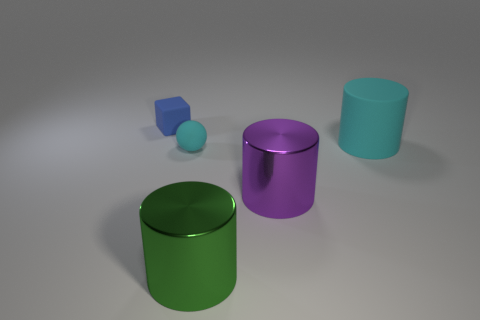Subtract all green cylinders. How many cylinders are left? 2 Subtract all purple cylinders. How many cylinders are left? 2 Add 3 big green things. How many objects exist? 8 Subtract 1 cylinders. How many cylinders are left? 2 Add 1 tiny blue matte blocks. How many tiny blue matte blocks are left? 2 Add 5 blue things. How many blue things exist? 6 Subtract 1 green cylinders. How many objects are left? 4 Subtract all balls. How many objects are left? 4 Subtract all cyan cylinders. Subtract all green cubes. How many cylinders are left? 2 Subtract all red balls. How many purple cylinders are left? 1 